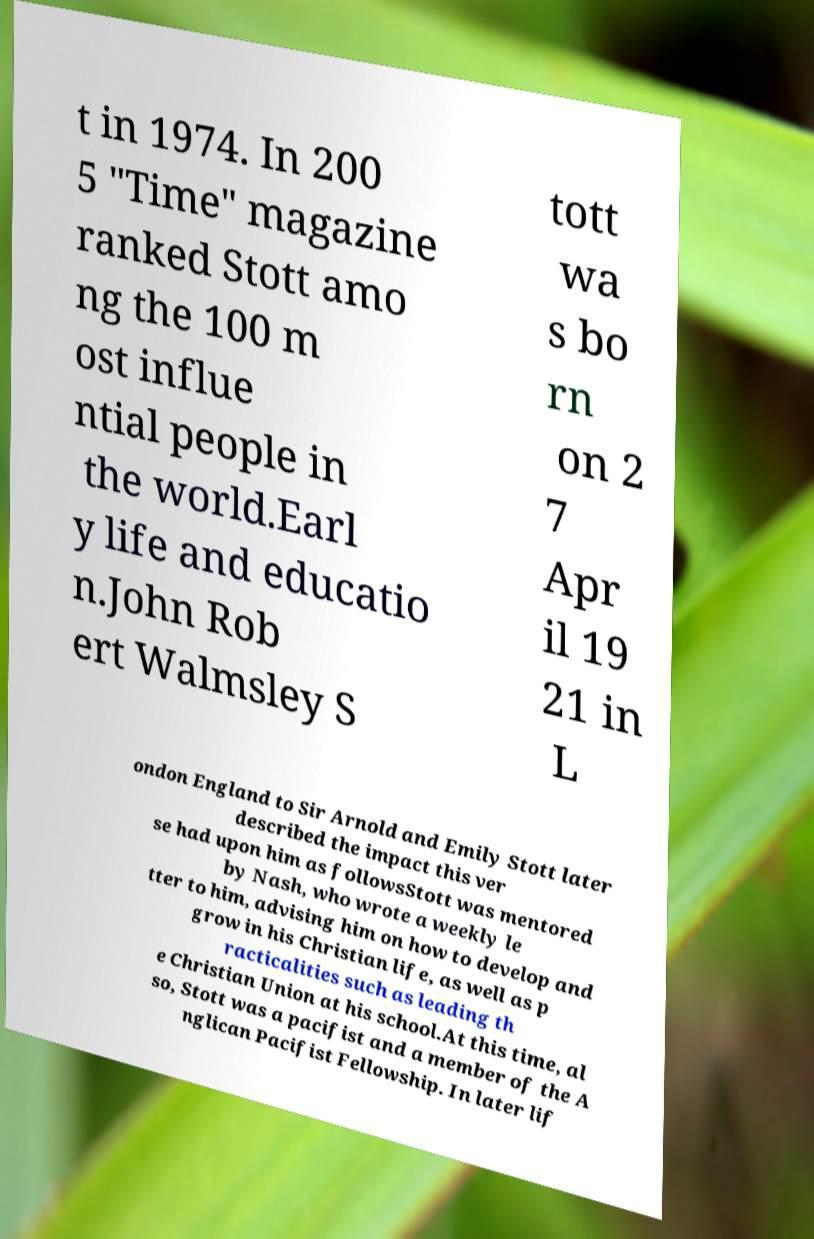Could you extract and type out the text from this image? t in 1974. In 200 5 "Time" magazine ranked Stott amo ng the 100 m ost influe ntial people in the world.Earl y life and educatio n.John Rob ert Walmsley S tott wa s bo rn on 2 7 Apr il 19 21 in L ondon England to Sir Arnold and Emily Stott later described the impact this ver se had upon him as followsStott was mentored by Nash, who wrote a weekly le tter to him, advising him on how to develop and grow in his Christian life, as well as p racticalities such as leading th e Christian Union at his school.At this time, al so, Stott was a pacifist and a member of the A nglican Pacifist Fellowship. In later lif 